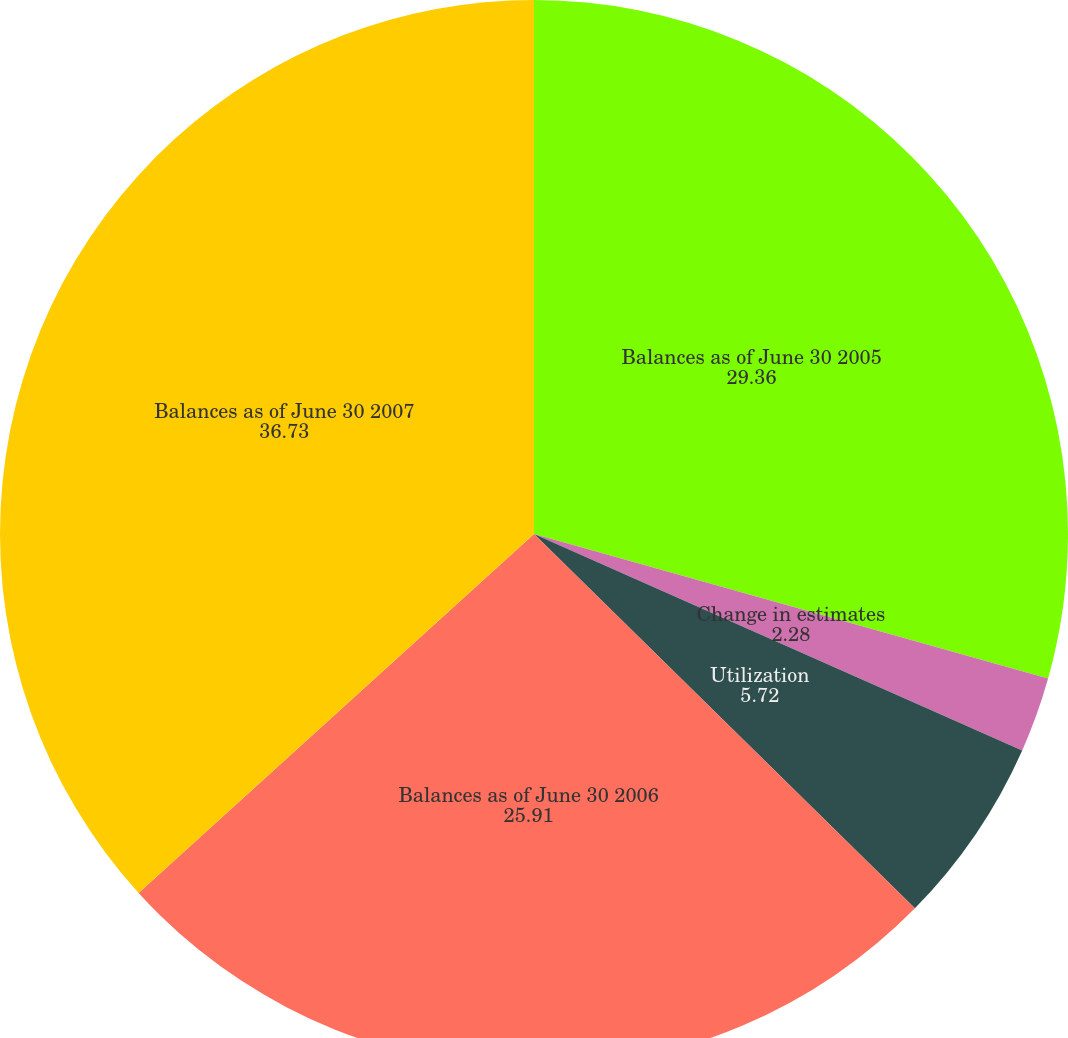Convert chart to OTSL. <chart><loc_0><loc_0><loc_500><loc_500><pie_chart><fcel>Balances as of June 30 2005<fcel>Change in estimates<fcel>Utilization<fcel>Balances as of June 30 2006<fcel>Balances as of June 30 2007<nl><fcel>29.36%<fcel>2.28%<fcel>5.72%<fcel>25.91%<fcel>36.73%<nl></chart> 